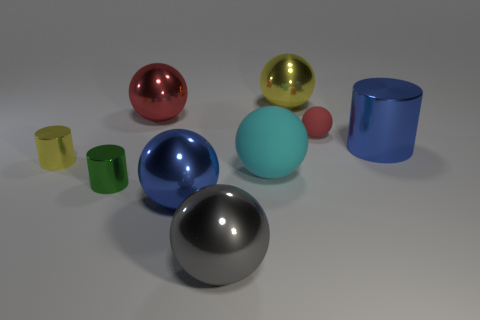Subtract all red matte balls. How many balls are left? 5 Subtract all red balls. How many balls are left? 4 Subtract all gray spheres. Subtract all green cylinders. How many spheres are left? 5 Add 1 big cyan metallic things. How many objects exist? 10 Subtract all balls. How many objects are left? 3 Subtract all small yellow metallic cylinders. Subtract all matte things. How many objects are left? 6 Add 2 yellow metal things. How many yellow metal things are left? 4 Add 8 small rubber balls. How many small rubber balls exist? 9 Subtract 1 gray balls. How many objects are left? 8 